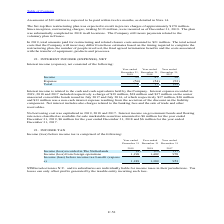According to Stmicroelectronics's financial document, What was the interest expense in 2018? According to the financial document, $38 million. The relevant text states: "017 included respectively a charge of $39 million, $38 million and $37 million on the senior unsecured convertible bonds issued in July 2017 and July 2014, of whic..." Also, What was the interest income in 2019? According to the financial document, $6 million. The relevant text states: "ailable-for-sale marketable securities amounted to $6 million for the year ended December 31, 2019, $6 million for the year ended December 31, 2018 and $6 million ailable-for-sale marketable securitie..." Also, What charges are included in Net interest? the banking fees and the sale of trade and other receivables.. The document states: "ent. Net interest includes also charges related to the banking fees and the sale of trade and other receivables...." Also, can you calculate: What is the average Income? To answer this question, I need to perform calculations using the financial data. The calculation is: (55+47+30) / 3, which equals 44 (in millions). This is based on the information: "Income 55 47 30 Income 55 47 30 Income 55 47 30..." The key data points involved are: 30, 47, 55. Also, can you calculate: What is the average Expense? To answer this question, I need to perform calculations using the financial data. The calculation is: (54+54+52) / 3, which equals 53.33 (in millions). This is based on the information: "Expense (54) (54) (52) Expense (54) (54) (52)..." The key data points involved are: 52, 54. Also, can you calculate: What is the increase/ (decrease) in income from December 31, 2018 to 2019? Based on the calculation: 55-47, the result is 8 (in millions). This is based on the information: "Income 55 47 30 Income 55 47 30..." The key data points involved are: 47, 55. 